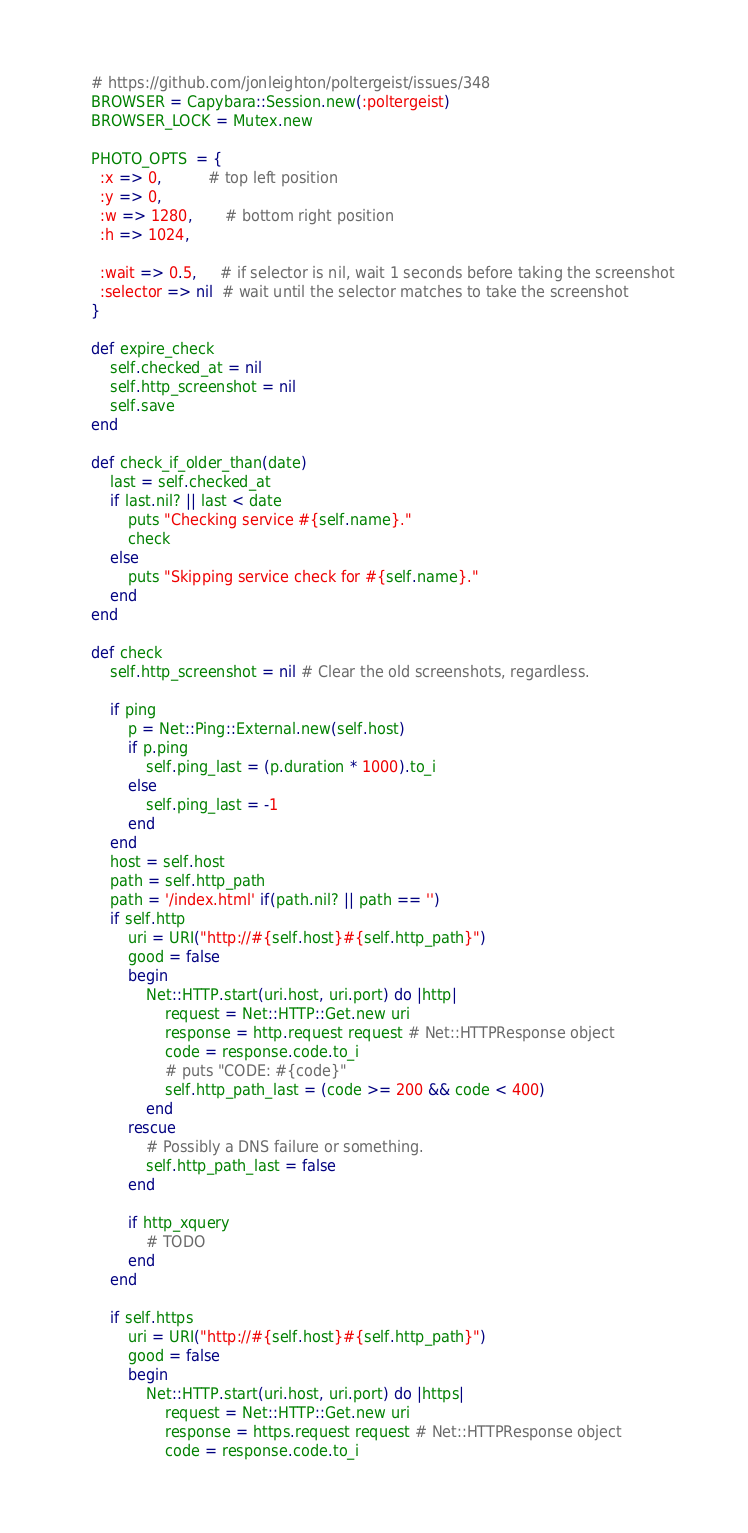Convert code to text. <code><loc_0><loc_0><loc_500><loc_500><_Ruby_>	# https://github.com/jonleighton/poltergeist/issues/348
	BROWSER = Capybara::Session.new(:poltergeist)
	BROWSER_LOCK = Mutex.new

	PHOTO_OPTS  = {
	  :x => 0,          # top left position
	  :y => 0,
	  :w => 1280,       # bottom right position
	  :h => 1024,
	
	  :wait => 0.5,     # if selector is nil, wait 1 seconds before taking the screenshot
	  :selector => nil  # wait until the selector matches to take the screenshot
	}

	def expire_check
		self.checked_at = nil
		self.http_screenshot = nil
		self.save
	end

	def check_if_older_than(date)
		last = self.checked_at
		if last.nil? || last < date
			puts "Checking service #{self.name}."
			check
		else
			puts "Skipping service check for #{self.name}."
		end
	end

	def check
		self.http_screenshot = nil # Clear the old screenshots, regardless.

		if ping
			p = Net::Ping::External.new(self.host)
			if p.ping
				self.ping_last = (p.duration * 1000).to_i
			else
				self.ping_last = -1
			end
		end
		host = self.host
		path = self.http_path
		path = '/index.html' if(path.nil? || path == '')
		if self.http			
			uri = URI("http://#{self.host}#{self.http_path}")
			good = false
			begin
				Net::HTTP.start(uri.host, uri.port) do |http|
					request = Net::HTTP::Get.new uri
					response = http.request request # Net::HTTPResponse object
					code = response.code.to_i
					# puts "CODE: #{code}"
					self.http_path_last = (code >= 200 && code < 400)
				end
			rescue
				# Possibly a DNS failure or something.
				self.http_path_last = false
			end

			if http_xquery
				# TODO
			end
		end

		if self.https
			uri = URI("http://#{self.host}#{self.http_path}")
			good = false
			begin
				Net::HTTP.start(uri.host, uri.port) do |https|
					request = Net::HTTP::Get.new uri
					response = https.request request # Net::HTTPResponse object
					code = response.code.to_i</code> 